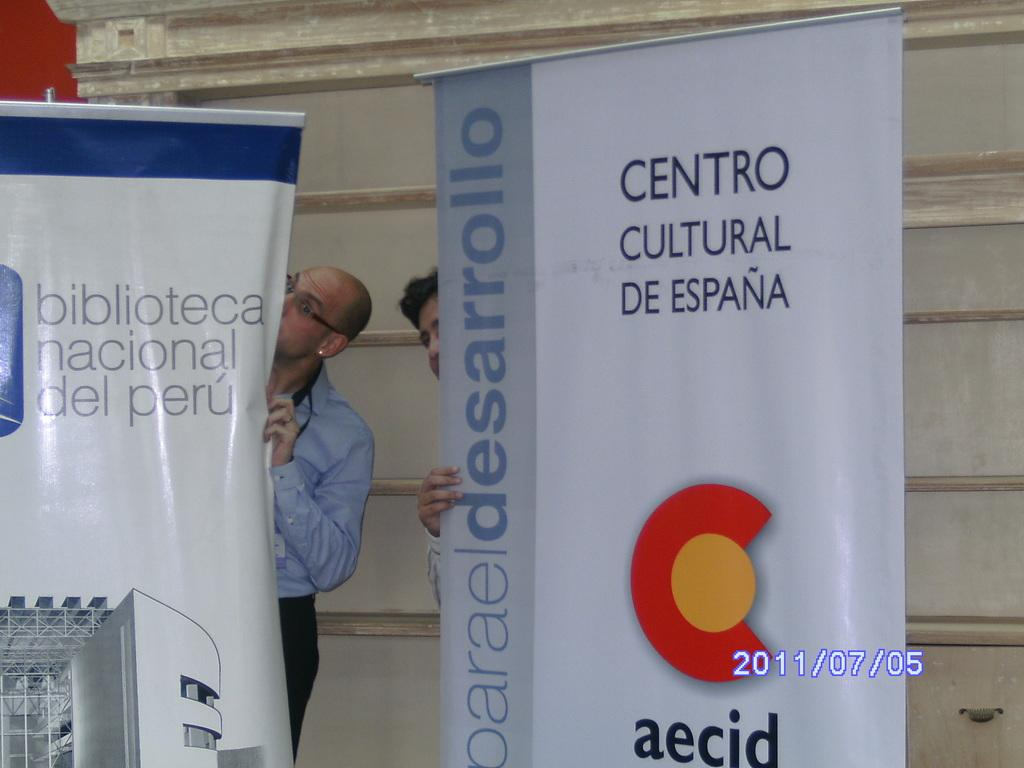<image>
Create a compact narrative representing the image presented. A sign that has the word centro on it 